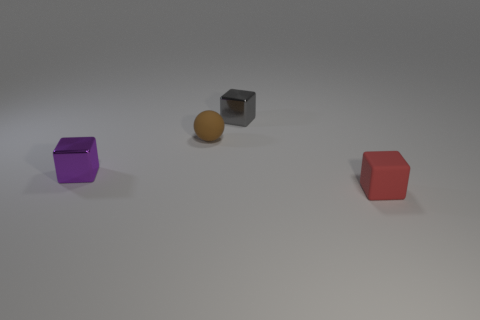How many things are rubber objects behind the red object or metal objects that are to the right of the small brown rubber sphere?
Your answer should be very brief. 2. There is a rubber thing that is behind the shiny object that is left of the small gray metallic cube; what shape is it?
Make the answer very short. Sphere. How many objects are either tiny blue rubber spheres or small matte cubes?
Your answer should be compact. 1. Is there a gray block that has the same size as the purple metal cube?
Keep it short and to the point. Yes. What is the shape of the gray object?
Your response must be concise. Cube. Is the number of purple metallic things that are in front of the tiny gray block greater than the number of small rubber cubes left of the small brown rubber thing?
Keep it short and to the point. Yes. What is the shape of the other rubber object that is the same size as the brown matte object?
Your response must be concise. Cube. Is there a purple thing that has the same shape as the red object?
Offer a very short reply. Yes. Do the small purple object in front of the rubber ball and the tiny block that is in front of the purple thing have the same material?
Your response must be concise. No. How many small purple blocks are made of the same material as the tiny gray block?
Keep it short and to the point. 1. 